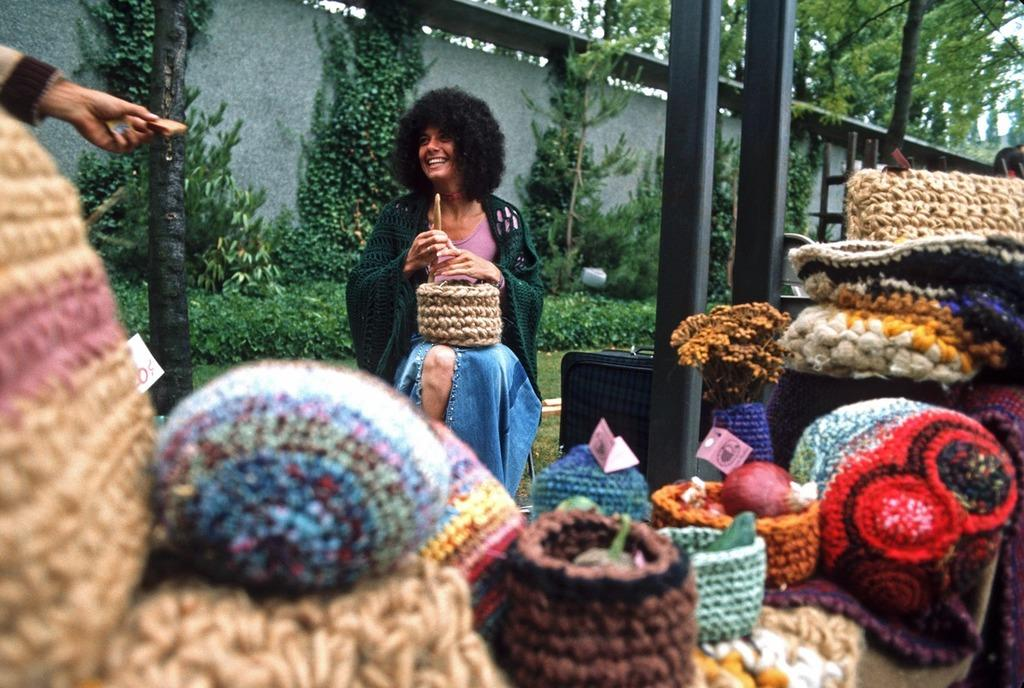How many people are present in the image? There are people in the image, but the exact number is not specified. What type of objects can be seen made of wool? There are woolen objects in the image, but their specific nature is not mentioned. What are the poles used for in the image? The purpose of the poles in the image is not clear from the given facts. What type of vegetation is visible in the image? Trees, plants, and grass are visible in the image. What part of the natural environment is visible in the image? The sky, ground, and vegetation are visible in the image. What is the purpose of the ladder in the image? The purpose of the ladder in the image is not specified. What type of heart can be seen beating in the image? There is no heart visible in the image. 